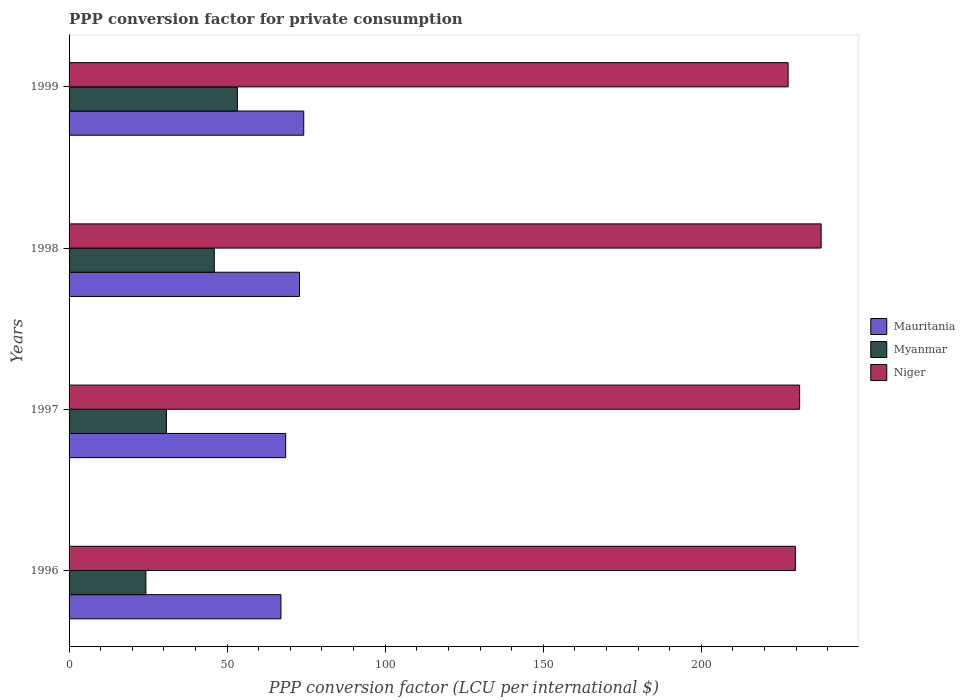How many different coloured bars are there?
Provide a short and direct response. 3. Are the number of bars per tick equal to the number of legend labels?
Provide a succinct answer. Yes. Are the number of bars on each tick of the Y-axis equal?
Provide a succinct answer. Yes. How many bars are there on the 1st tick from the top?
Provide a short and direct response. 3. How many bars are there on the 2nd tick from the bottom?
Your answer should be very brief. 3. What is the label of the 4th group of bars from the top?
Your answer should be compact. 1996. In how many cases, is the number of bars for a given year not equal to the number of legend labels?
Offer a very short reply. 0. What is the PPP conversion factor for private consumption in Niger in 1997?
Your response must be concise. 231.08. Across all years, what is the maximum PPP conversion factor for private consumption in Mauritania?
Give a very brief answer. 74.23. Across all years, what is the minimum PPP conversion factor for private consumption in Mauritania?
Your answer should be compact. 67.01. In which year was the PPP conversion factor for private consumption in Myanmar maximum?
Your answer should be very brief. 1999. In which year was the PPP conversion factor for private consumption in Mauritania minimum?
Provide a succinct answer. 1996. What is the total PPP conversion factor for private consumption in Mauritania in the graph?
Provide a succinct answer. 282.64. What is the difference between the PPP conversion factor for private consumption in Mauritania in 1996 and that in 1999?
Your response must be concise. -7.21. What is the difference between the PPP conversion factor for private consumption in Niger in 1997 and the PPP conversion factor for private consumption in Mauritania in 1999?
Keep it short and to the point. 156.85. What is the average PPP conversion factor for private consumption in Myanmar per year?
Provide a short and direct response. 38.56. In the year 1996, what is the difference between the PPP conversion factor for private consumption in Niger and PPP conversion factor for private consumption in Mauritania?
Keep it short and to the point. 162.73. What is the ratio of the PPP conversion factor for private consumption in Myanmar in 1998 to that in 1999?
Provide a short and direct response. 0.86. What is the difference between the highest and the second highest PPP conversion factor for private consumption in Myanmar?
Provide a succinct answer. 7.29. What is the difference between the highest and the lowest PPP conversion factor for private consumption in Myanmar?
Ensure brevity in your answer.  28.93. In how many years, is the PPP conversion factor for private consumption in Niger greater than the average PPP conversion factor for private consumption in Niger taken over all years?
Make the answer very short. 1. Is the sum of the PPP conversion factor for private consumption in Niger in 1996 and 1997 greater than the maximum PPP conversion factor for private consumption in Mauritania across all years?
Ensure brevity in your answer.  Yes. What does the 1st bar from the top in 1997 represents?
Provide a succinct answer. Niger. What does the 1st bar from the bottom in 1997 represents?
Give a very brief answer. Mauritania. Are the values on the major ticks of X-axis written in scientific E-notation?
Ensure brevity in your answer.  No. Does the graph contain any zero values?
Provide a succinct answer. No. How many legend labels are there?
Offer a terse response. 3. What is the title of the graph?
Ensure brevity in your answer.  PPP conversion factor for private consumption. Does "South Sudan" appear as one of the legend labels in the graph?
Offer a very short reply. No. What is the label or title of the X-axis?
Give a very brief answer. PPP conversion factor (LCU per international $). What is the label or title of the Y-axis?
Your answer should be very brief. Years. What is the PPP conversion factor (LCU per international $) of Mauritania in 1996?
Keep it short and to the point. 67.01. What is the PPP conversion factor (LCU per international $) in Myanmar in 1996?
Offer a very short reply. 24.3. What is the PPP conversion factor (LCU per international $) in Niger in 1996?
Your response must be concise. 229.75. What is the PPP conversion factor (LCU per international $) of Mauritania in 1997?
Make the answer very short. 68.51. What is the PPP conversion factor (LCU per international $) in Myanmar in 1997?
Ensure brevity in your answer.  30.8. What is the PPP conversion factor (LCU per international $) in Niger in 1997?
Your response must be concise. 231.08. What is the PPP conversion factor (LCU per international $) in Mauritania in 1998?
Ensure brevity in your answer.  72.88. What is the PPP conversion factor (LCU per international $) in Myanmar in 1998?
Offer a very short reply. 45.94. What is the PPP conversion factor (LCU per international $) of Niger in 1998?
Ensure brevity in your answer.  237.9. What is the PPP conversion factor (LCU per international $) in Mauritania in 1999?
Make the answer very short. 74.23. What is the PPP conversion factor (LCU per international $) of Myanmar in 1999?
Keep it short and to the point. 53.23. What is the PPP conversion factor (LCU per international $) in Niger in 1999?
Provide a succinct answer. 227.45. Across all years, what is the maximum PPP conversion factor (LCU per international $) of Mauritania?
Your answer should be compact. 74.23. Across all years, what is the maximum PPP conversion factor (LCU per international $) in Myanmar?
Give a very brief answer. 53.23. Across all years, what is the maximum PPP conversion factor (LCU per international $) in Niger?
Ensure brevity in your answer.  237.9. Across all years, what is the minimum PPP conversion factor (LCU per international $) of Mauritania?
Your answer should be compact. 67.01. Across all years, what is the minimum PPP conversion factor (LCU per international $) in Myanmar?
Your answer should be compact. 24.3. Across all years, what is the minimum PPP conversion factor (LCU per international $) in Niger?
Your answer should be very brief. 227.45. What is the total PPP conversion factor (LCU per international $) of Mauritania in the graph?
Provide a short and direct response. 282.64. What is the total PPP conversion factor (LCU per international $) in Myanmar in the graph?
Give a very brief answer. 154.26. What is the total PPP conversion factor (LCU per international $) of Niger in the graph?
Keep it short and to the point. 926.18. What is the difference between the PPP conversion factor (LCU per international $) in Mauritania in 1996 and that in 1997?
Offer a terse response. -1.5. What is the difference between the PPP conversion factor (LCU per international $) of Myanmar in 1996 and that in 1997?
Offer a terse response. -6.5. What is the difference between the PPP conversion factor (LCU per international $) in Niger in 1996 and that in 1997?
Your response must be concise. -1.34. What is the difference between the PPP conversion factor (LCU per international $) in Mauritania in 1996 and that in 1998?
Keep it short and to the point. -5.87. What is the difference between the PPP conversion factor (LCU per international $) of Myanmar in 1996 and that in 1998?
Offer a very short reply. -21.64. What is the difference between the PPP conversion factor (LCU per international $) of Niger in 1996 and that in 1998?
Give a very brief answer. -8.15. What is the difference between the PPP conversion factor (LCU per international $) in Mauritania in 1996 and that in 1999?
Keep it short and to the point. -7.21. What is the difference between the PPP conversion factor (LCU per international $) in Myanmar in 1996 and that in 1999?
Give a very brief answer. -28.93. What is the difference between the PPP conversion factor (LCU per international $) of Niger in 1996 and that in 1999?
Keep it short and to the point. 2.3. What is the difference between the PPP conversion factor (LCU per international $) in Mauritania in 1997 and that in 1998?
Offer a terse response. -4.37. What is the difference between the PPP conversion factor (LCU per international $) in Myanmar in 1997 and that in 1998?
Keep it short and to the point. -15.14. What is the difference between the PPP conversion factor (LCU per international $) of Niger in 1997 and that in 1998?
Your answer should be very brief. -6.82. What is the difference between the PPP conversion factor (LCU per international $) in Mauritania in 1997 and that in 1999?
Provide a short and direct response. -5.72. What is the difference between the PPP conversion factor (LCU per international $) in Myanmar in 1997 and that in 1999?
Your answer should be compact. -22.43. What is the difference between the PPP conversion factor (LCU per international $) in Niger in 1997 and that in 1999?
Your response must be concise. 3.64. What is the difference between the PPP conversion factor (LCU per international $) in Mauritania in 1998 and that in 1999?
Give a very brief answer. -1.35. What is the difference between the PPP conversion factor (LCU per international $) of Myanmar in 1998 and that in 1999?
Your response must be concise. -7.29. What is the difference between the PPP conversion factor (LCU per international $) in Niger in 1998 and that in 1999?
Offer a terse response. 10.45. What is the difference between the PPP conversion factor (LCU per international $) in Mauritania in 1996 and the PPP conversion factor (LCU per international $) in Myanmar in 1997?
Offer a terse response. 36.22. What is the difference between the PPP conversion factor (LCU per international $) in Mauritania in 1996 and the PPP conversion factor (LCU per international $) in Niger in 1997?
Ensure brevity in your answer.  -164.07. What is the difference between the PPP conversion factor (LCU per international $) of Myanmar in 1996 and the PPP conversion factor (LCU per international $) of Niger in 1997?
Your answer should be compact. -206.78. What is the difference between the PPP conversion factor (LCU per international $) of Mauritania in 1996 and the PPP conversion factor (LCU per international $) of Myanmar in 1998?
Give a very brief answer. 21.08. What is the difference between the PPP conversion factor (LCU per international $) of Mauritania in 1996 and the PPP conversion factor (LCU per international $) of Niger in 1998?
Ensure brevity in your answer.  -170.89. What is the difference between the PPP conversion factor (LCU per international $) in Myanmar in 1996 and the PPP conversion factor (LCU per international $) in Niger in 1998?
Ensure brevity in your answer.  -213.6. What is the difference between the PPP conversion factor (LCU per international $) of Mauritania in 1996 and the PPP conversion factor (LCU per international $) of Myanmar in 1999?
Keep it short and to the point. 13.79. What is the difference between the PPP conversion factor (LCU per international $) of Mauritania in 1996 and the PPP conversion factor (LCU per international $) of Niger in 1999?
Provide a short and direct response. -160.43. What is the difference between the PPP conversion factor (LCU per international $) of Myanmar in 1996 and the PPP conversion factor (LCU per international $) of Niger in 1999?
Provide a succinct answer. -203.15. What is the difference between the PPP conversion factor (LCU per international $) in Mauritania in 1997 and the PPP conversion factor (LCU per international $) in Myanmar in 1998?
Ensure brevity in your answer.  22.57. What is the difference between the PPP conversion factor (LCU per international $) in Mauritania in 1997 and the PPP conversion factor (LCU per international $) in Niger in 1998?
Your response must be concise. -169.39. What is the difference between the PPP conversion factor (LCU per international $) of Myanmar in 1997 and the PPP conversion factor (LCU per international $) of Niger in 1998?
Provide a short and direct response. -207.1. What is the difference between the PPP conversion factor (LCU per international $) of Mauritania in 1997 and the PPP conversion factor (LCU per international $) of Myanmar in 1999?
Provide a succinct answer. 15.29. What is the difference between the PPP conversion factor (LCU per international $) in Mauritania in 1997 and the PPP conversion factor (LCU per international $) in Niger in 1999?
Ensure brevity in your answer.  -158.93. What is the difference between the PPP conversion factor (LCU per international $) of Myanmar in 1997 and the PPP conversion factor (LCU per international $) of Niger in 1999?
Give a very brief answer. -196.65. What is the difference between the PPP conversion factor (LCU per international $) of Mauritania in 1998 and the PPP conversion factor (LCU per international $) of Myanmar in 1999?
Your answer should be compact. 19.66. What is the difference between the PPP conversion factor (LCU per international $) in Mauritania in 1998 and the PPP conversion factor (LCU per international $) in Niger in 1999?
Your answer should be compact. -154.56. What is the difference between the PPP conversion factor (LCU per international $) of Myanmar in 1998 and the PPP conversion factor (LCU per international $) of Niger in 1999?
Give a very brief answer. -181.51. What is the average PPP conversion factor (LCU per international $) in Mauritania per year?
Provide a short and direct response. 70.66. What is the average PPP conversion factor (LCU per international $) of Myanmar per year?
Your answer should be compact. 38.56. What is the average PPP conversion factor (LCU per international $) of Niger per year?
Your response must be concise. 231.54. In the year 1996, what is the difference between the PPP conversion factor (LCU per international $) in Mauritania and PPP conversion factor (LCU per international $) in Myanmar?
Keep it short and to the point. 42.72. In the year 1996, what is the difference between the PPP conversion factor (LCU per international $) in Mauritania and PPP conversion factor (LCU per international $) in Niger?
Keep it short and to the point. -162.73. In the year 1996, what is the difference between the PPP conversion factor (LCU per international $) of Myanmar and PPP conversion factor (LCU per international $) of Niger?
Make the answer very short. -205.45. In the year 1997, what is the difference between the PPP conversion factor (LCU per international $) in Mauritania and PPP conversion factor (LCU per international $) in Myanmar?
Give a very brief answer. 37.72. In the year 1997, what is the difference between the PPP conversion factor (LCU per international $) of Mauritania and PPP conversion factor (LCU per international $) of Niger?
Make the answer very short. -162.57. In the year 1997, what is the difference between the PPP conversion factor (LCU per international $) in Myanmar and PPP conversion factor (LCU per international $) in Niger?
Keep it short and to the point. -200.29. In the year 1998, what is the difference between the PPP conversion factor (LCU per international $) in Mauritania and PPP conversion factor (LCU per international $) in Myanmar?
Offer a very short reply. 26.95. In the year 1998, what is the difference between the PPP conversion factor (LCU per international $) in Mauritania and PPP conversion factor (LCU per international $) in Niger?
Provide a succinct answer. -165.02. In the year 1998, what is the difference between the PPP conversion factor (LCU per international $) of Myanmar and PPP conversion factor (LCU per international $) of Niger?
Provide a succinct answer. -191.96. In the year 1999, what is the difference between the PPP conversion factor (LCU per international $) in Mauritania and PPP conversion factor (LCU per international $) in Myanmar?
Offer a very short reply. 21. In the year 1999, what is the difference between the PPP conversion factor (LCU per international $) of Mauritania and PPP conversion factor (LCU per international $) of Niger?
Your answer should be compact. -153.22. In the year 1999, what is the difference between the PPP conversion factor (LCU per international $) of Myanmar and PPP conversion factor (LCU per international $) of Niger?
Ensure brevity in your answer.  -174.22. What is the ratio of the PPP conversion factor (LCU per international $) of Mauritania in 1996 to that in 1997?
Provide a short and direct response. 0.98. What is the ratio of the PPP conversion factor (LCU per international $) of Myanmar in 1996 to that in 1997?
Provide a succinct answer. 0.79. What is the ratio of the PPP conversion factor (LCU per international $) of Niger in 1996 to that in 1997?
Offer a terse response. 0.99. What is the ratio of the PPP conversion factor (LCU per international $) in Mauritania in 1996 to that in 1998?
Keep it short and to the point. 0.92. What is the ratio of the PPP conversion factor (LCU per international $) in Myanmar in 1996 to that in 1998?
Offer a terse response. 0.53. What is the ratio of the PPP conversion factor (LCU per international $) of Niger in 1996 to that in 1998?
Ensure brevity in your answer.  0.97. What is the ratio of the PPP conversion factor (LCU per international $) of Mauritania in 1996 to that in 1999?
Ensure brevity in your answer.  0.9. What is the ratio of the PPP conversion factor (LCU per international $) of Myanmar in 1996 to that in 1999?
Offer a terse response. 0.46. What is the ratio of the PPP conversion factor (LCU per international $) of Myanmar in 1997 to that in 1998?
Offer a terse response. 0.67. What is the ratio of the PPP conversion factor (LCU per international $) in Niger in 1997 to that in 1998?
Your answer should be compact. 0.97. What is the ratio of the PPP conversion factor (LCU per international $) of Mauritania in 1997 to that in 1999?
Offer a terse response. 0.92. What is the ratio of the PPP conversion factor (LCU per international $) of Myanmar in 1997 to that in 1999?
Make the answer very short. 0.58. What is the ratio of the PPP conversion factor (LCU per international $) in Niger in 1997 to that in 1999?
Ensure brevity in your answer.  1.02. What is the ratio of the PPP conversion factor (LCU per international $) of Mauritania in 1998 to that in 1999?
Offer a very short reply. 0.98. What is the ratio of the PPP conversion factor (LCU per international $) in Myanmar in 1998 to that in 1999?
Make the answer very short. 0.86. What is the ratio of the PPP conversion factor (LCU per international $) of Niger in 1998 to that in 1999?
Provide a short and direct response. 1.05. What is the difference between the highest and the second highest PPP conversion factor (LCU per international $) of Mauritania?
Ensure brevity in your answer.  1.35. What is the difference between the highest and the second highest PPP conversion factor (LCU per international $) of Myanmar?
Give a very brief answer. 7.29. What is the difference between the highest and the second highest PPP conversion factor (LCU per international $) of Niger?
Keep it short and to the point. 6.82. What is the difference between the highest and the lowest PPP conversion factor (LCU per international $) in Mauritania?
Provide a short and direct response. 7.21. What is the difference between the highest and the lowest PPP conversion factor (LCU per international $) in Myanmar?
Make the answer very short. 28.93. What is the difference between the highest and the lowest PPP conversion factor (LCU per international $) of Niger?
Make the answer very short. 10.45. 